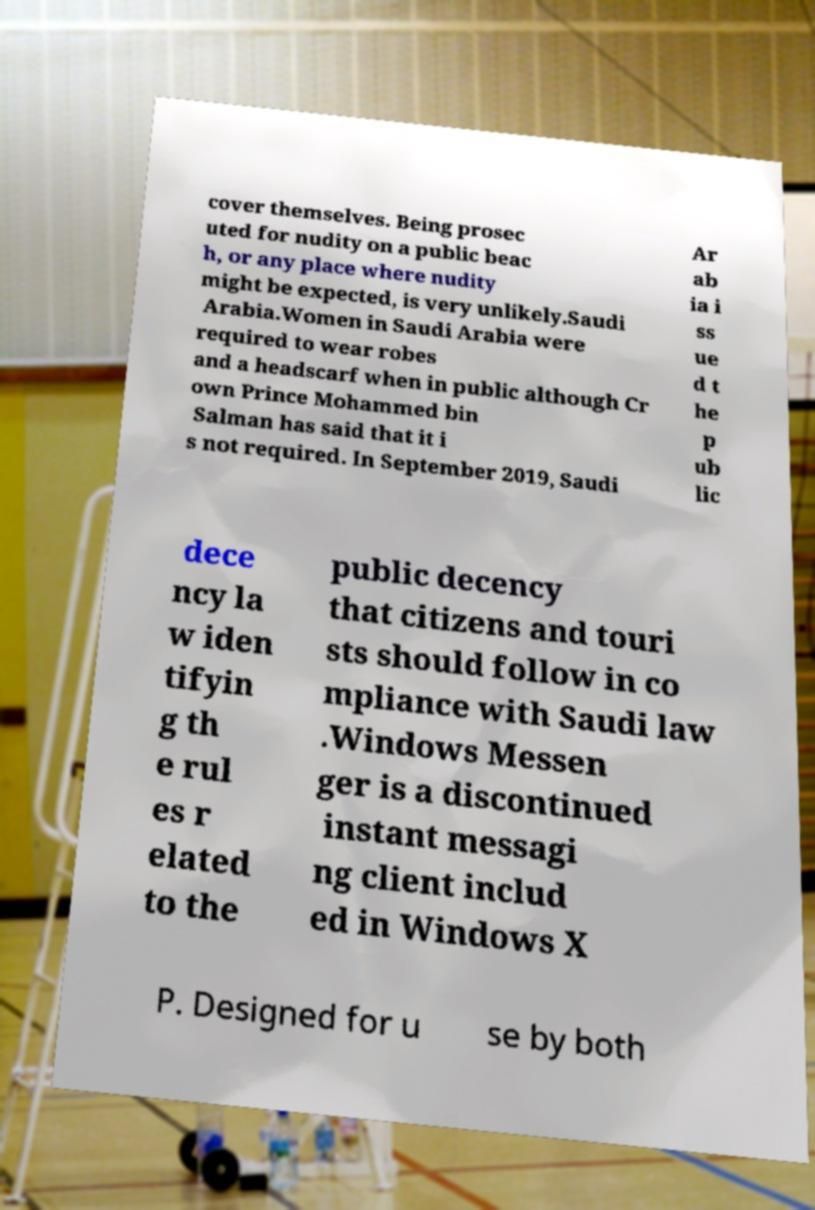Could you extract and type out the text from this image? cover themselves. Being prosec uted for nudity on a public beac h, or any place where nudity might be expected, is very unlikely.Saudi Arabia.Women in Saudi Arabia were required to wear robes and a headscarf when in public although Cr own Prince Mohammed bin Salman has said that it i s not required. In September 2019, Saudi Ar ab ia i ss ue d t he p ub lic dece ncy la w iden tifyin g th e rul es r elated to the public decency that citizens and touri sts should follow in co mpliance with Saudi law .Windows Messen ger is a discontinued instant messagi ng client includ ed in Windows X P. Designed for u se by both 